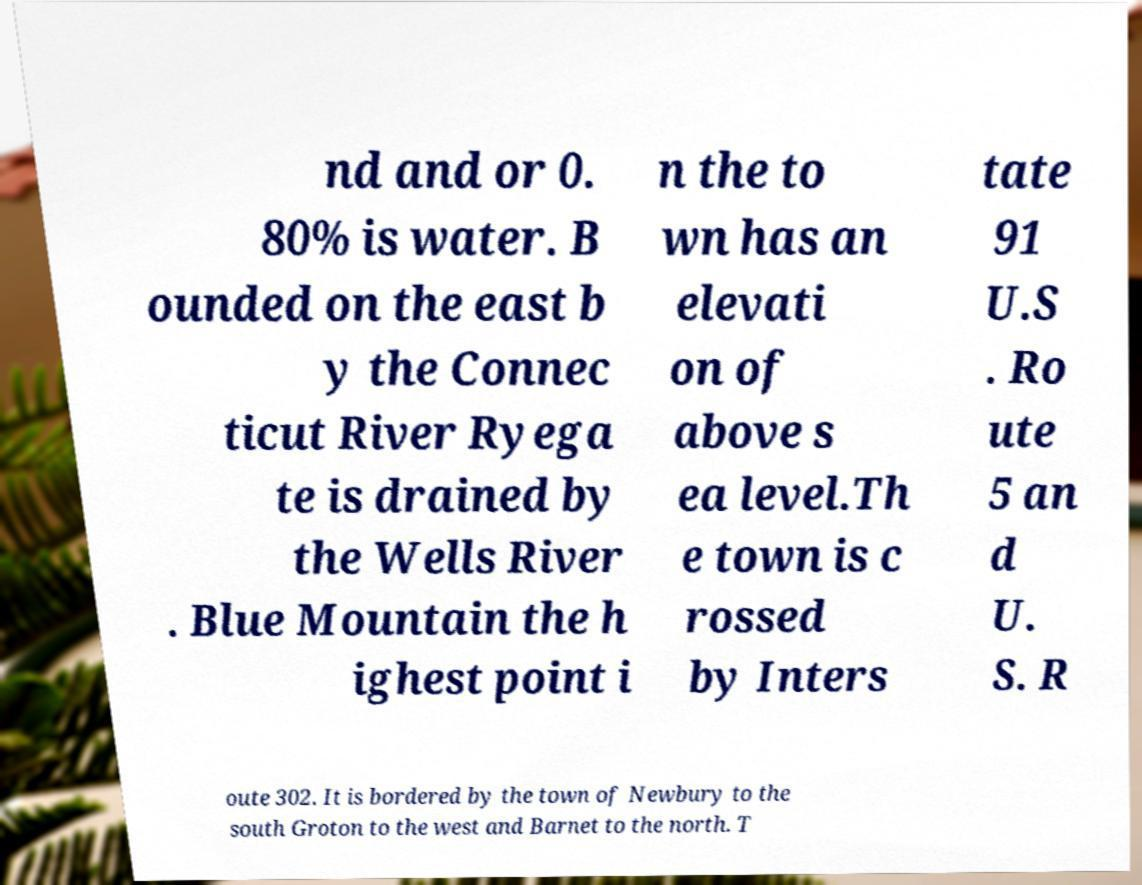Could you assist in decoding the text presented in this image and type it out clearly? nd and or 0. 80% is water. B ounded on the east b y the Connec ticut River Ryega te is drained by the Wells River . Blue Mountain the h ighest point i n the to wn has an elevati on of above s ea level.Th e town is c rossed by Inters tate 91 U.S . Ro ute 5 an d U. S. R oute 302. It is bordered by the town of Newbury to the south Groton to the west and Barnet to the north. T 